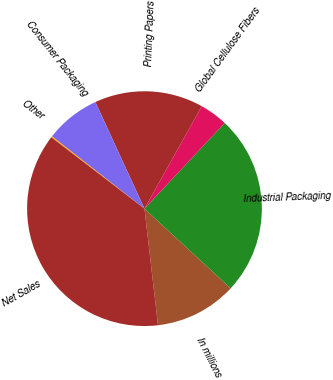Convert chart to OTSL. <chart><loc_0><loc_0><loc_500><loc_500><pie_chart><fcel>In millions<fcel>Industrial Packaging<fcel>Global Cellulose Fibers<fcel>Printing Papers<fcel>Consumer Packaging<fcel>Other<fcel>Net Sales<nl><fcel>11.28%<fcel>24.9%<fcel>3.86%<fcel>14.99%<fcel>7.57%<fcel>0.16%<fcel>37.24%<nl></chart> 